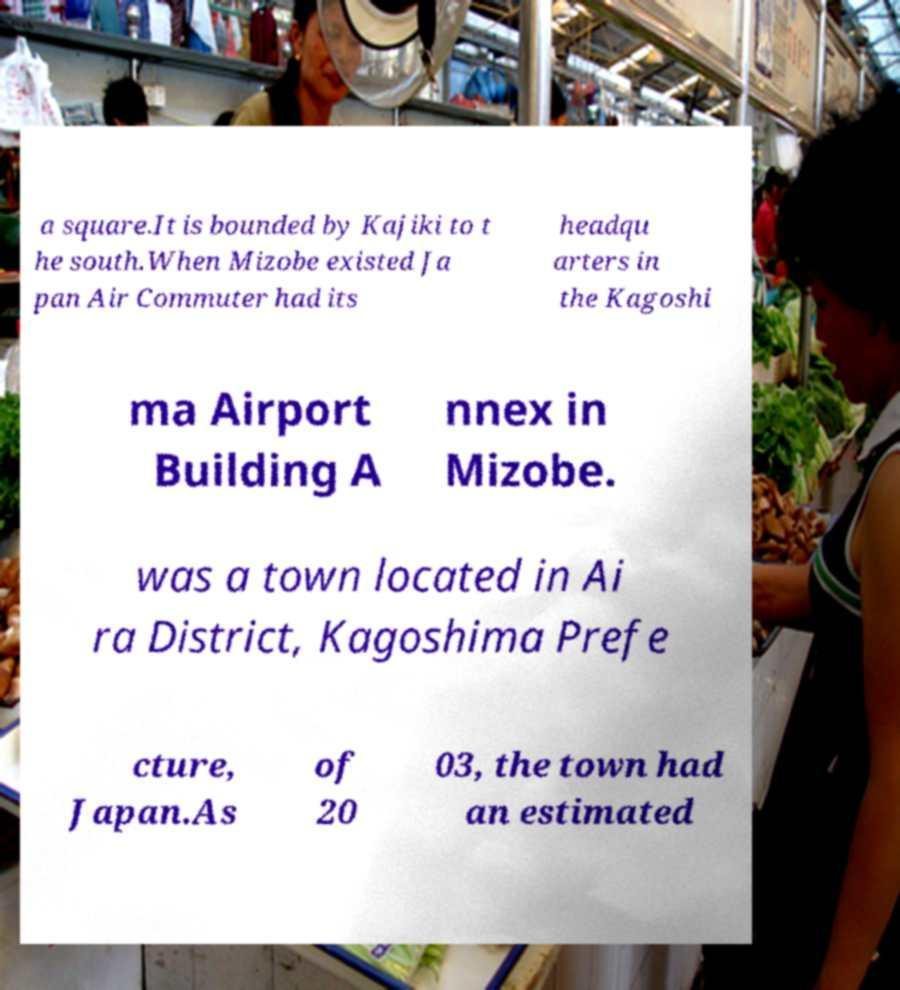Can you read and provide the text displayed in the image?This photo seems to have some interesting text. Can you extract and type it out for me? a square.It is bounded by Kajiki to t he south.When Mizobe existed Ja pan Air Commuter had its headqu arters in the Kagoshi ma Airport Building A nnex in Mizobe. was a town located in Ai ra District, Kagoshima Prefe cture, Japan.As of 20 03, the town had an estimated 